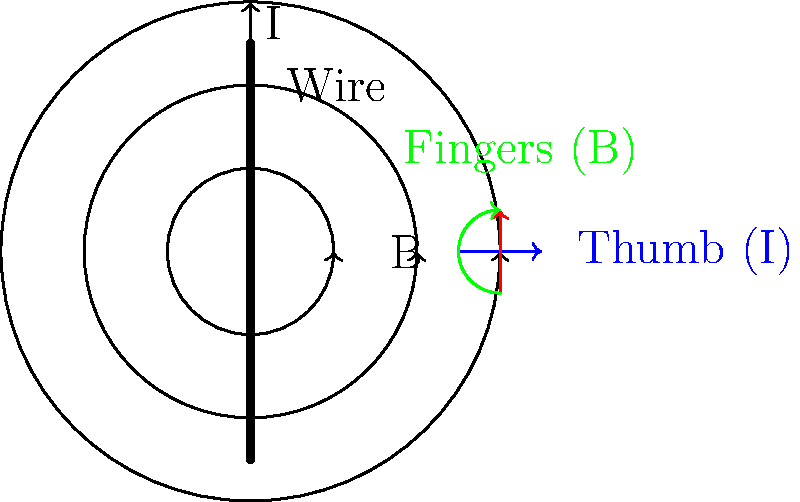As a longtime colleague of Daniel J O'Connor, you're familiar with his work on electromagnetic fields. Consider a long, straight wire carrying a current I. Using the right-hand rule, how would you determine the direction of the magnetic field B at a point P located 5 cm to the right of the wire? What is the magnitude of the magnetic field at this point if the current is 2 A? To solve this problem, let's follow these steps:

1. Determine the direction of the magnetic field:
   - Use the right-hand rule: point your thumb in the direction of the current (upwards in this case).
   - Your fingers will curl around the wire in the direction of the magnetic field.
   - For a point to the right of the wire, the magnetic field will be pointing into the page (or clockwise when viewed from above).

2. Calculate the magnitude of the magnetic field:
   - The magnetic field strength B around a long, straight wire is given by the equation:
     
     $$B = \frac{\mu_0 I}{2\pi r}$$
     
     where:
     $\mu_0$ is the permeability of free space ($4\pi \times 10^{-7}$ T·m/A)
     $I$ is the current in the wire (2 A)
     $r$ is the distance from the wire to the point P (0.05 m)

3. Plug in the values:
   
   $$B = \frac{(4\pi \times 10^{-7})(2)}{2\pi(0.05)}$$

4. Simplify:
   
   $$B = \frac{4\pi \times 10^{-7} \times 2}{2\pi \times 0.05} = \frac{8 \times 10^{-7}}{0.1\pi} = 8 \times 10^{-6}$$ T

5. Round to significant figures:
   
   $$B \approx 8.0 \times 10^{-6}$$ T
Answer: Direction: into the page; Magnitude: $8.0 \times 10^{-6}$ T 